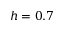<formula> <loc_0><loc_0><loc_500><loc_500>h = 0 . 7</formula> 